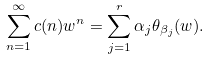<formula> <loc_0><loc_0><loc_500><loc_500>\sum _ { n = 1 } ^ { \infty } c ( n ) w ^ { n } = \sum _ { j = 1 } ^ { r } \alpha _ { j } \theta _ { \beta _ { j } } ( w ) .</formula> 